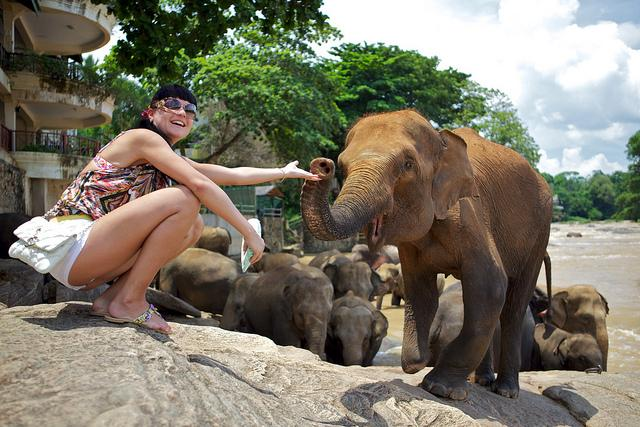What is climbing up the rocks to talk to the woman who is on the top? elephant 